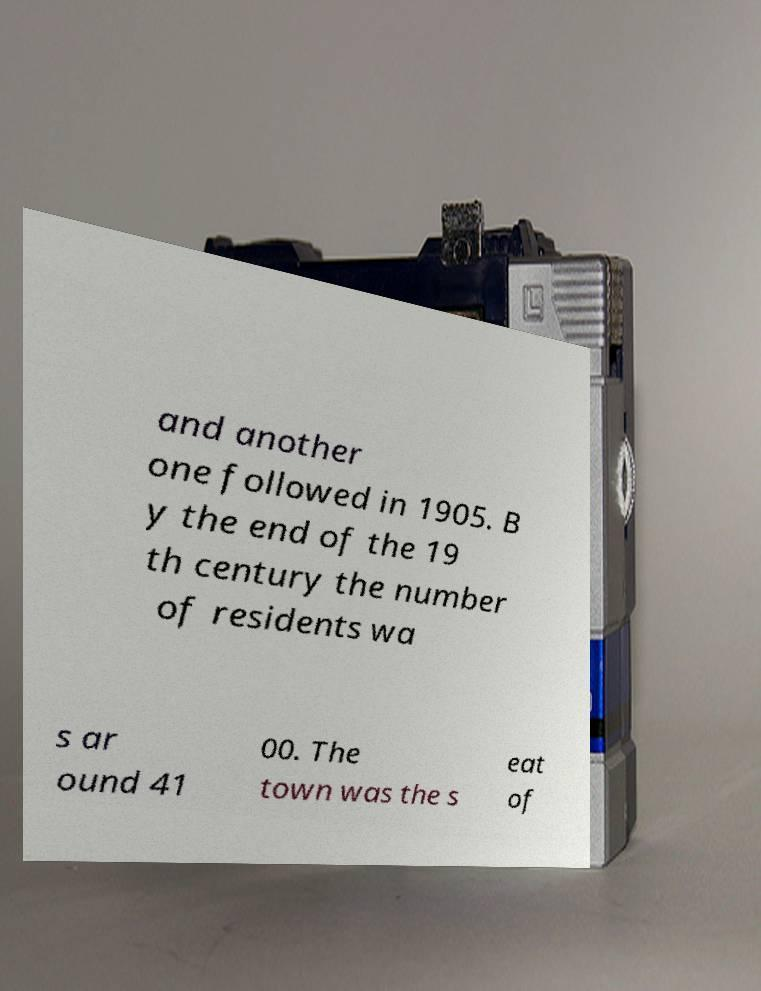Please identify and transcribe the text found in this image. and another one followed in 1905. B y the end of the 19 th century the number of residents wa s ar ound 41 00. The town was the s eat of 